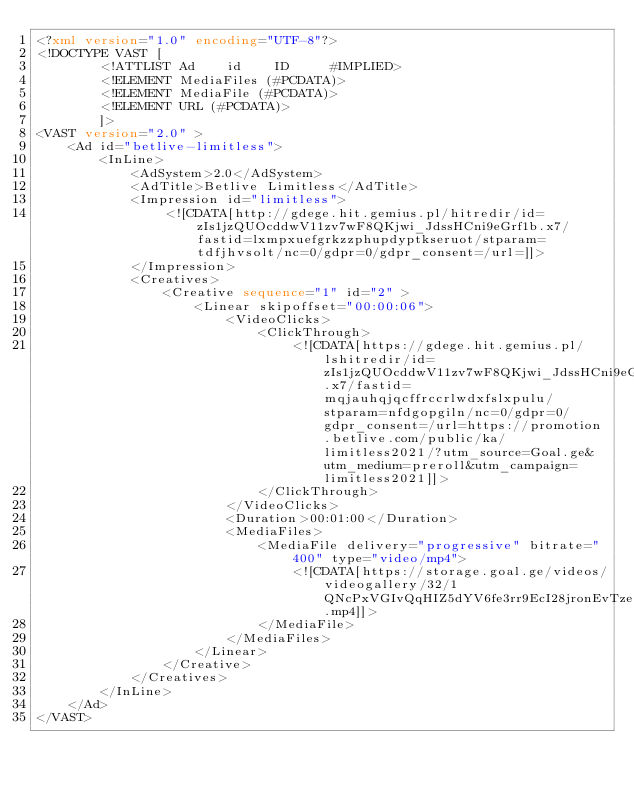Convert code to text. <code><loc_0><loc_0><loc_500><loc_500><_XML_><?xml version="1.0" encoding="UTF-8"?>
<!DOCTYPE VAST [
        <!ATTLIST Ad    id    ID     #IMPLIED>
        <!ELEMENT MediaFiles (#PCDATA)>
        <!ELEMENT MediaFile (#PCDATA)>
        <!ELEMENT URL (#PCDATA)>
        ]>
<VAST version="2.0" >
    <Ad id="betlive-limitless">
        <InLine>
            <AdSystem>2.0</AdSystem>
            <AdTitle>Betlive Limitless</AdTitle>
            <Impression id="limitless">
                <![CDATA[http://gdege.hit.gemius.pl/hitredir/id=zIs1jzQUOcddwV11zv7wF8QKjwi_JdssHCni9eGrf1b.x7/fastid=lxmpxuefgrkzzphupdyptkseruot/stparam=tdfjhvsolt/nc=0/gdpr=0/gdpr_consent=/url=]]>
            </Impression>
            <Creatives>
                <Creative sequence="1" id="2" >
                    <Linear skipoffset="00:00:06">
                        <VideoClicks>
                            <ClickThrough>
                                <![CDATA[https://gdege.hit.gemius.pl/lshitredir/id=zIs1jzQUOcddwV11zv7wF8QKjwi_JdssHCni9eGrf1b.x7/fastid=mqjauhqjqcffrccrlwdxfslxpulu/stparam=nfdgopgiln/nc=0/gdpr=0/gdpr_consent=/url=https://promotion.betlive.com/public/ka/limitless2021/?utm_source=Goal.ge&utm_medium=preroll&utm_campaign=limitless2021]]>
                            </ClickThrough>
                        </VideoClicks>
                        <Duration>00:01:00</Duration>
                        <MediaFiles>
                            <MediaFile delivery="progressive" bitrate="400" type="video/mp4">
                                <![CDATA[https://storage.goal.ge/videos/videogallery/32/1QNcPxVGIvQqHIZ5dYV6fe3rr9EcI28jronEvTze.mp4]]>
                            </MediaFile>
                        </MediaFiles>
                    </Linear>
                </Creative>
            </Creatives>
        </InLine>
    </Ad>
</VAST>
</code> 